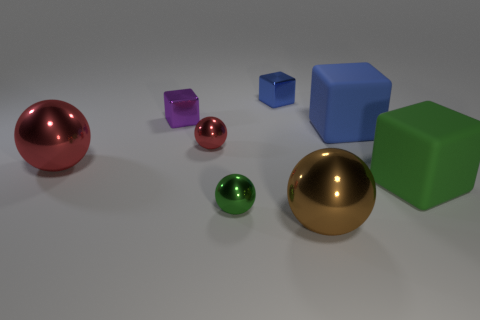Subtract 1 balls. How many balls are left? 3 Add 2 matte things. How many objects exist? 10 Subtract all red balls. Subtract all cubes. How many objects are left? 2 Add 7 small red metallic objects. How many small red metallic objects are left? 8 Add 6 big yellow metallic cylinders. How many big yellow metallic cylinders exist? 6 Subtract 1 blue blocks. How many objects are left? 7 